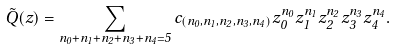<formula> <loc_0><loc_0><loc_500><loc_500>\tilde { Q } ( z ) = \sum _ { n _ { 0 } + n _ { 1 } + n _ { 2 } + n _ { 3 } + n _ { 4 } = 5 } c _ { ( n _ { 0 } , n _ { 1 } , n _ { 2 } , n _ { 3 } , n _ { 4 } ) } z _ { 0 } ^ { n _ { 0 } } z _ { 1 } ^ { n _ { 1 } } z _ { 2 } ^ { n _ { 2 } } z _ { 3 } ^ { n _ { 3 } } z _ { 4 } ^ { n _ { 4 } } .</formula> 